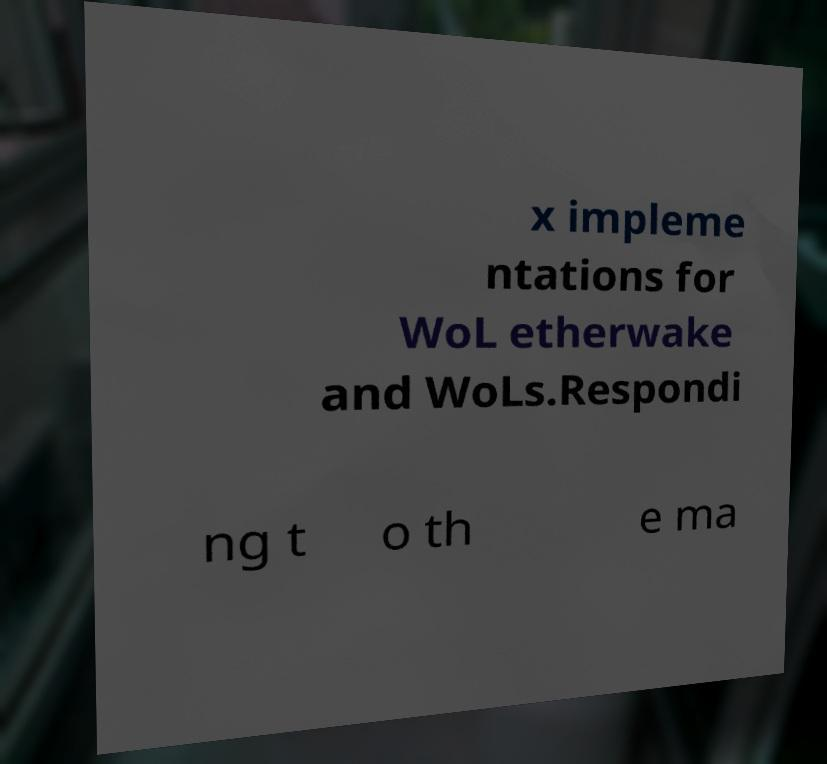Can you read and provide the text displayed in the image?This photo seems to have some interesting text. Can you extract and type it out for me? x impleme ntations for WoL etherwake and WoLs.Respondi ng t o th e ma 